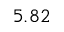<formula> <loc_0><loc_0><loc_500><loc_500>5 . 8 2</formula> 